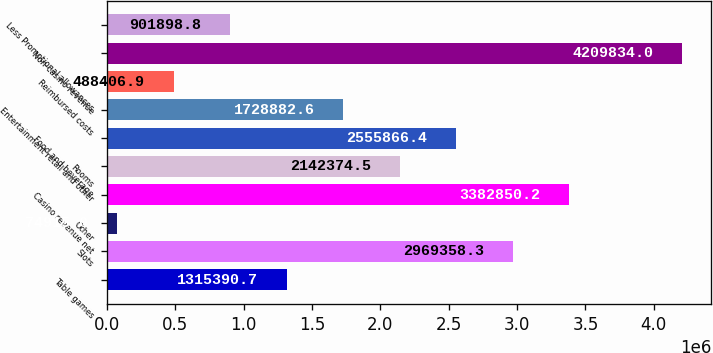Convert chart. <chart><loc_0><loc_0><loc_500><loc_500><bar_chart><fcel>Table games<fcel>Slots<fcel>Other<fcel>Casino revenue net<fcel>Rooms<fcel>Food and beverage<fcel>Entertainment retail and other<fcel>Reimbursed costs<fcel>Non-casino revenue<fcel>Less Promotional allowances<nl><fcel>1.31539e+06<fcel>2.96936e+06<fcel>74915<fcel>3.38285e+06<fcel>2.14237e+06<fcel>2.55587e+06<fcel>1.72888e+06<fcel>488407<fcel>4.20983e+06<fcel>901899<nl></chart> 